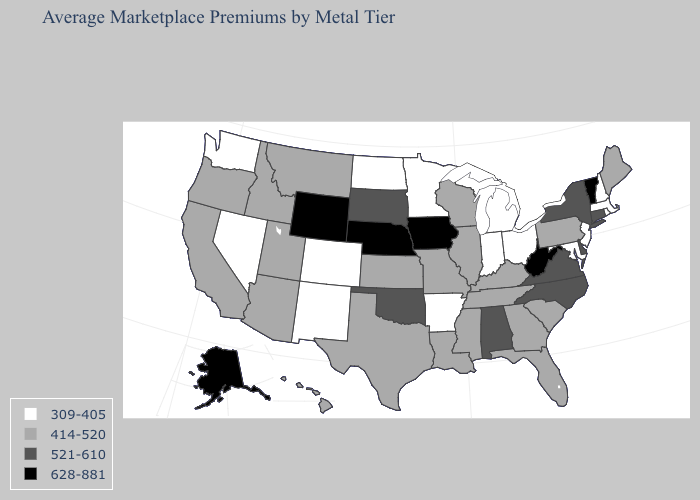Name the states that have a value in the range 309-405?
Answer briefly. Arkansas, Colorado, Indiana, Maryland, Massachusetts, Michigan, Minnesota, Nevada, New Hampshire, New Jersey, New Mexico, North Dakota, Ohio, Rhode Island, Washington. Among the states that border Kentucky , does Tennessee have the lowest value?
Answer briefly. No. Which states have the lowest value in the USA?
Quick response, please. Arkansas, Colorado, Indiana, Maryland, Massachusetts, Michigan, Minnesota, Nevada, New Hampshire, New Jersey, New Mexico, North Dakota, Ohio, Rhode Island, Washington. Does the map have missing data?
Short answer required. No. Does the map have missing data?
Short answer required. No. Name the states that have a value in the range 309-405?
Short answer required. Arkansas, Colorado, Indiana, Maryland, Massachusetts, Michigan, Minnesota, Nevada, New Hampshire, New Jersey, New Mexico, North Dakota, Ohio, Rhode Island, Washington. How many symbols are there in the legend?
Write a very short answer. 4. What is the value of Kansas?
Short answer required. 414-520. Does the map have missing data?
Answer briefly. No. What is the value of Connecticut?
Keep it brief. 521-610. Which states hav the highest value in the West?
Be succinct. Alaska, Wyoming. What is the value of Michigan?
Concise answer only. 309-405. Name the states that have a value in the range 628-881?
Quick response, please. Alaska, Iowa, Nebraska, Vermont, West Virginia, Wyoming. What is the highest value in states that border Idaho?
Keep it brief. 628-881. Which states have the highest value in the USA?
Short answer required. Alaska, Iowa, Nebraska, Vermont, West Virginia, Wyoming. 